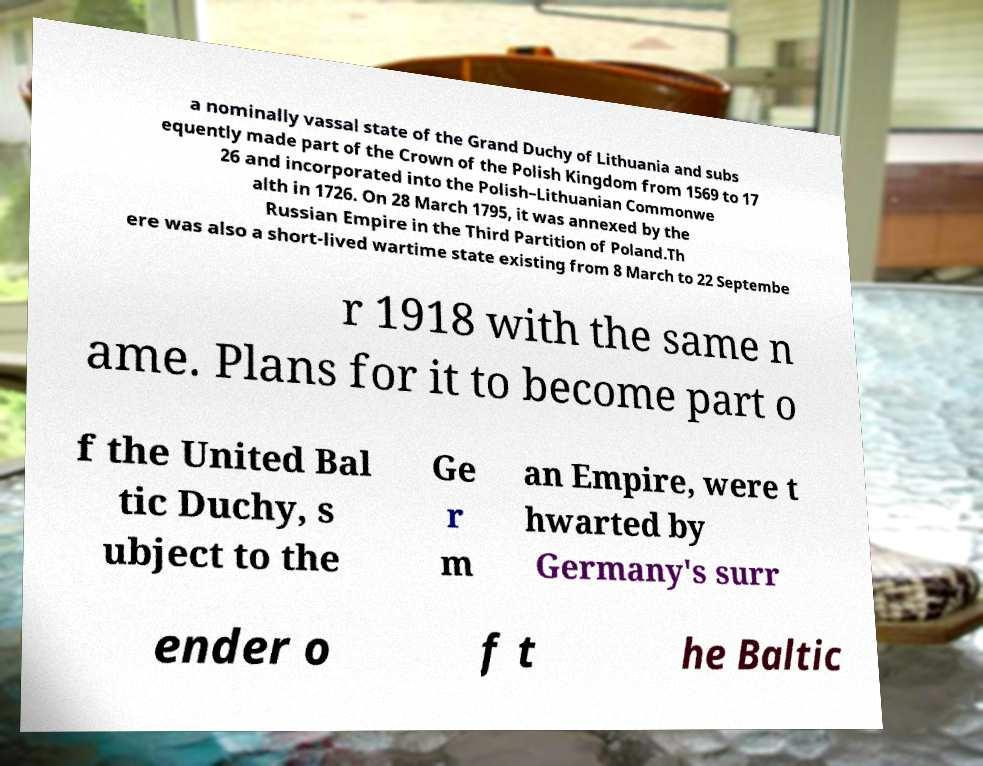Can you read and provide the text displayed in the image?This photo seems to have some interesting text. Can you extract and type it out for me? a nominally vassal state of the Grand Duchy of Lithuania and subs equently made part of the Crown of the Polish Kingdom from 1569 to 17 26 and incorporated into the Polish–Lithuanian Commonwe alth in 1726. On 28 March 1795, it was annexed by the Russian Empire in the Third Partition of Poland.Th ere was also a short-lived wartime state existing from 8 March to 22 Septembe r 1918 with the same n ame. Plans for it to become part o f the United Bal tic Duchy, s ubject to the Ge r m an Empire, were t hwarted by Germany's surr ender o f t he Baltic 